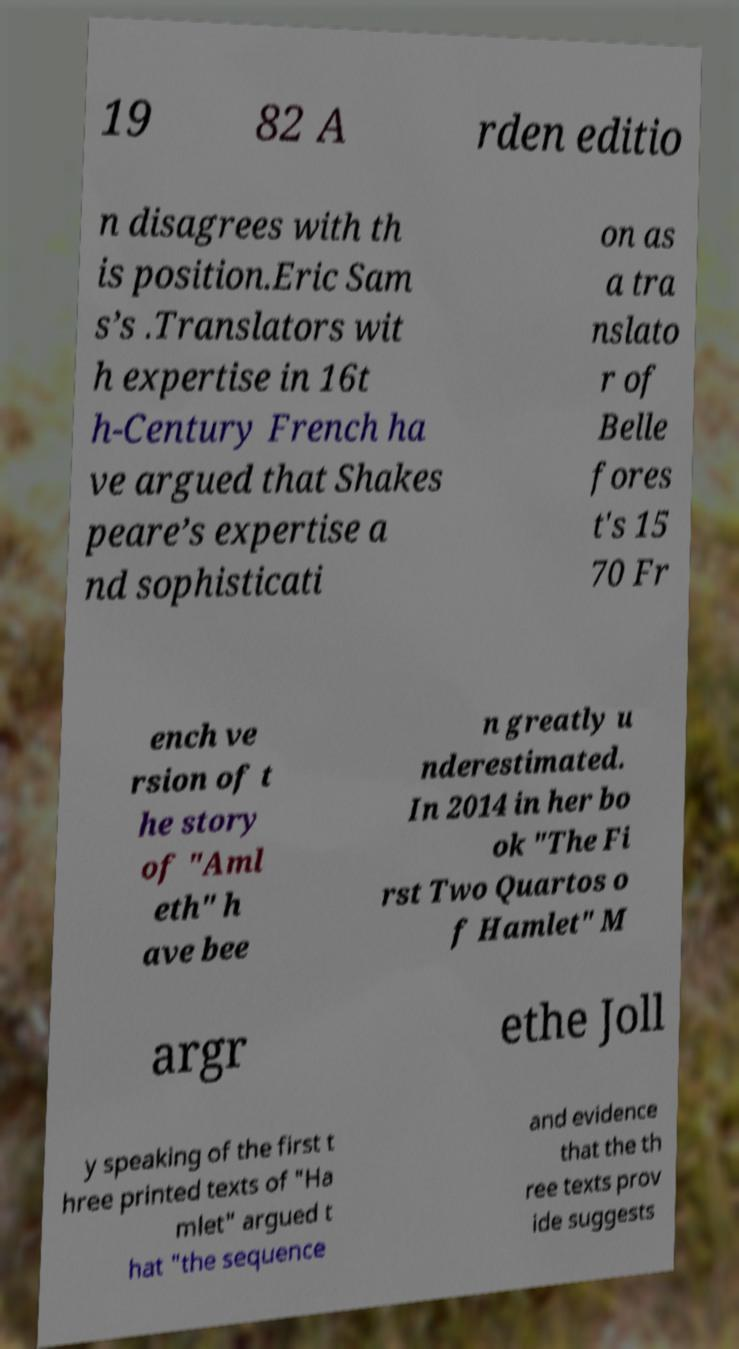Could you assist in decoding the text presented in this image and type it out clearly? 19 82 A rden editio n disagrees with th is position.Eric Sam s’s .Translators wit h expertise in 16t h-Century French ha ve argued that Shakes peare’s expertise a nd sophisticati on as a tra nslato r of Belle fores t's 15 70 Fr ench ve rsion of t he story of "Aml eth" h ave bee n greatly u nderestimated. In 2014 in her bo ok "The Fi rst Two Quartos o f Hamlet" M argr ethe Joll y speaking of the first t hree printed texts of "Ha mlet" argued t hat "the sequence and evidence that the th ree texts prov ide suggests 